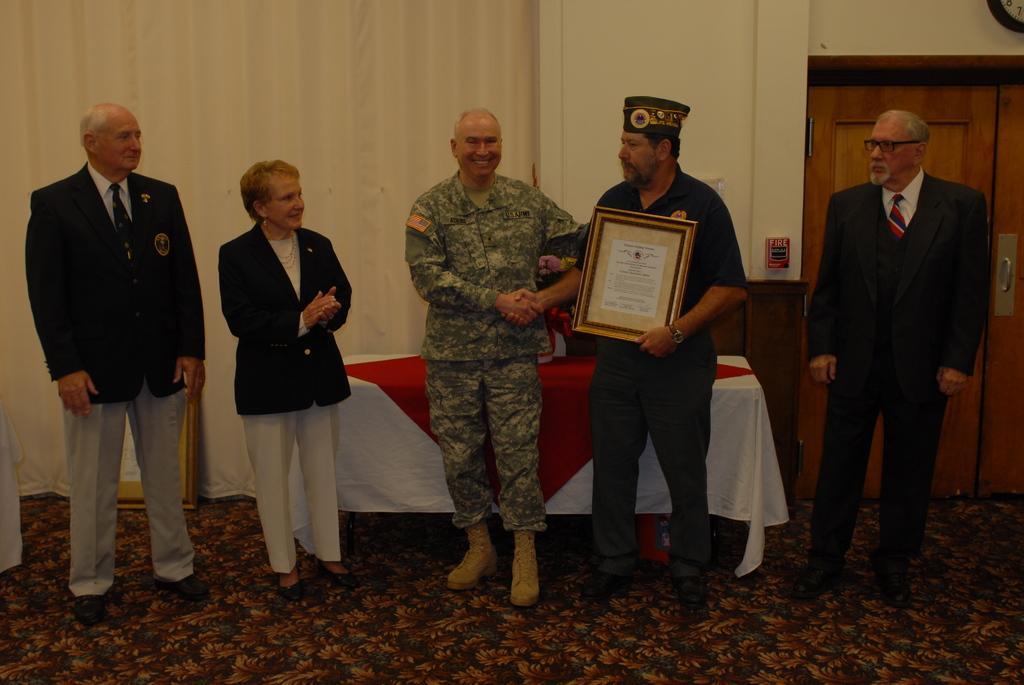Can you describe this image briefly? In this image we can see people standing. The man standing in the center is holding a frame. There is a table. In the background there is a curtain and we can see a door. At the bottom there is a carpet and we can see a frame. 